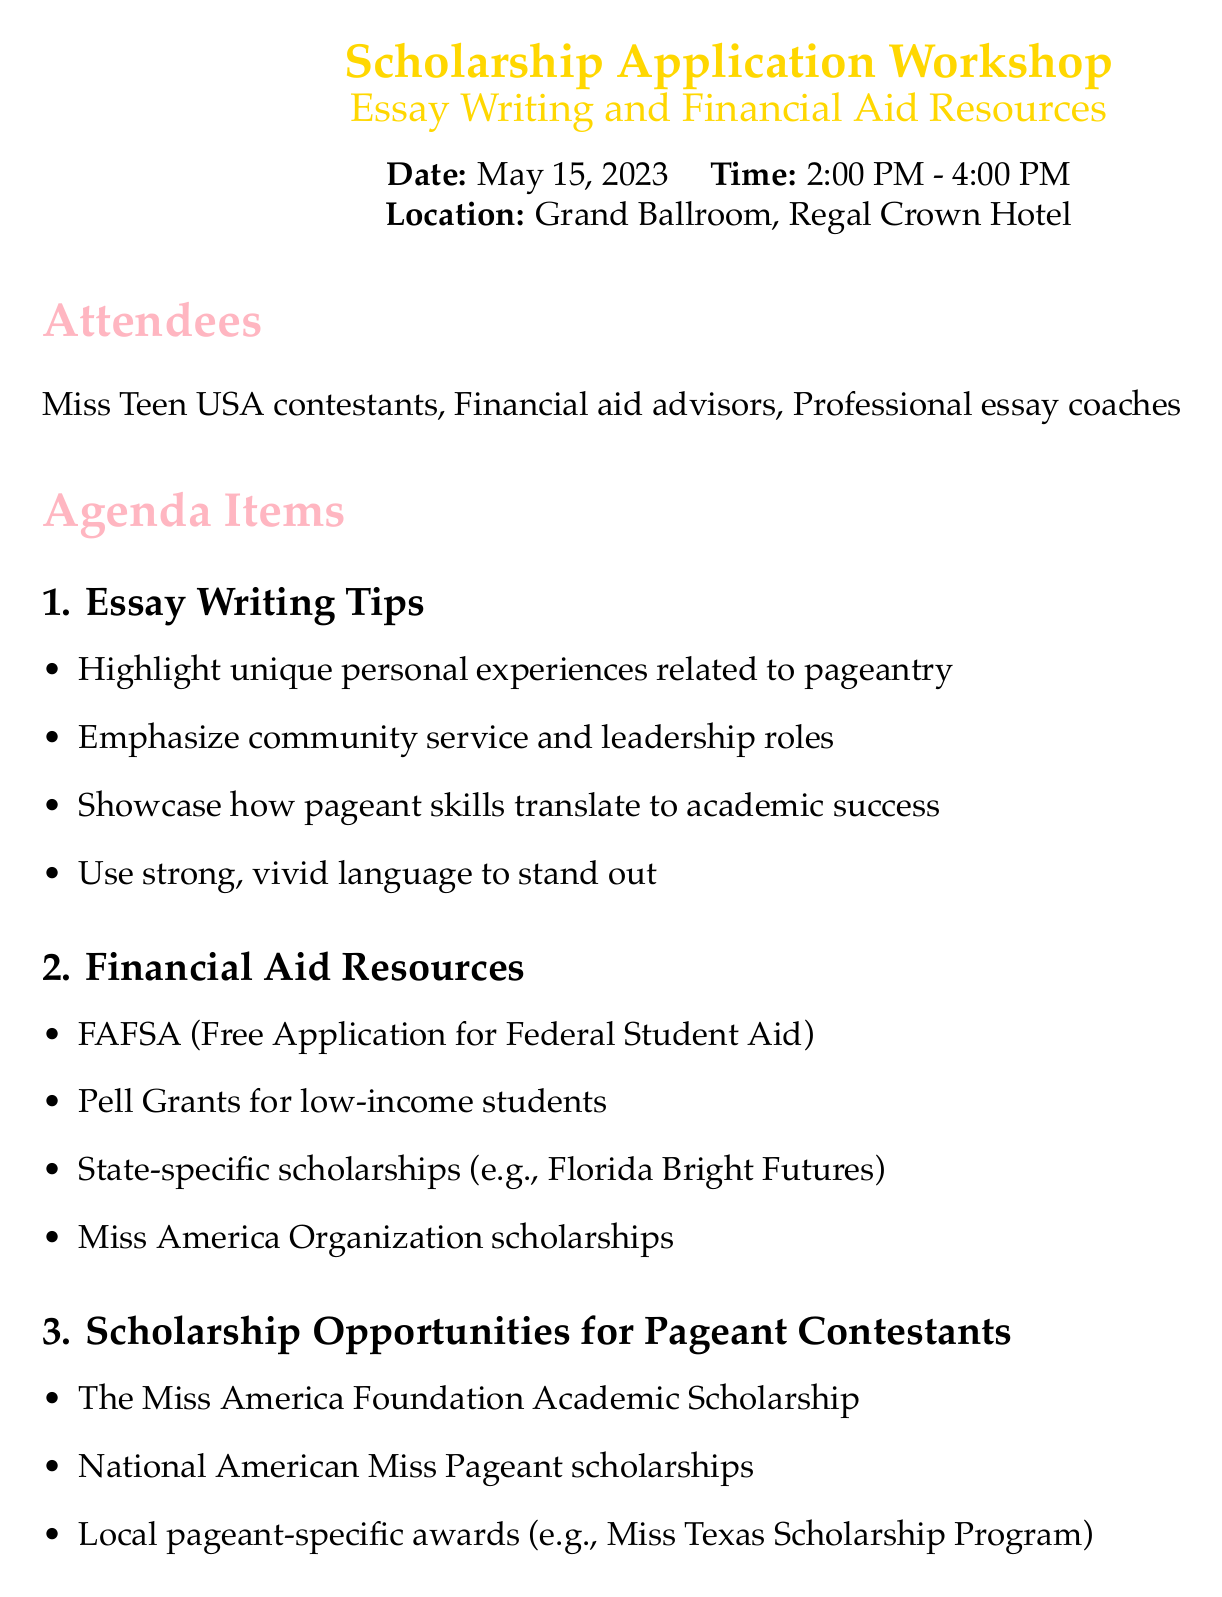What is the date of the workshop? The date of the workshop is clearly stated in the document.
Answer: May 15, 2023 Who were the attendees at the workshop? The attendees are listed in the document, detailing who participated.
Answer: Miss Teen USA contestants, Financial aid advisors, Professional essay coaches What is one essay writing tip mentioned? The document lists key points under the Essay Writing Tips section.
Answer: Highlight unique personal experiences related to pageantry Name one financial aid resource provided. Several key points are mentioned under Financial Aid Resources in the document.
Answer: FAFSA (Free Application for Federal Student Aid) How many action items were discussed? The number of action items can be counted from the corresponding section in the document.
Answer: Four What type of scholarships are highlighted for pageant contestants? The document has a specific section detailing scholarships for pageant contestants.
Answer: The Miss America Foundation Academic Scholarship When is the follow-up workshop scheduled? The next steps section specifies the date of the follow-up workshop.
Answer: June 1, 2023 What is the title of the essay writing guide provided? The document provides a title under the Resources Provided section.
Answer: 'From Crown to Campus: Crafting Your Scholarship Story' 